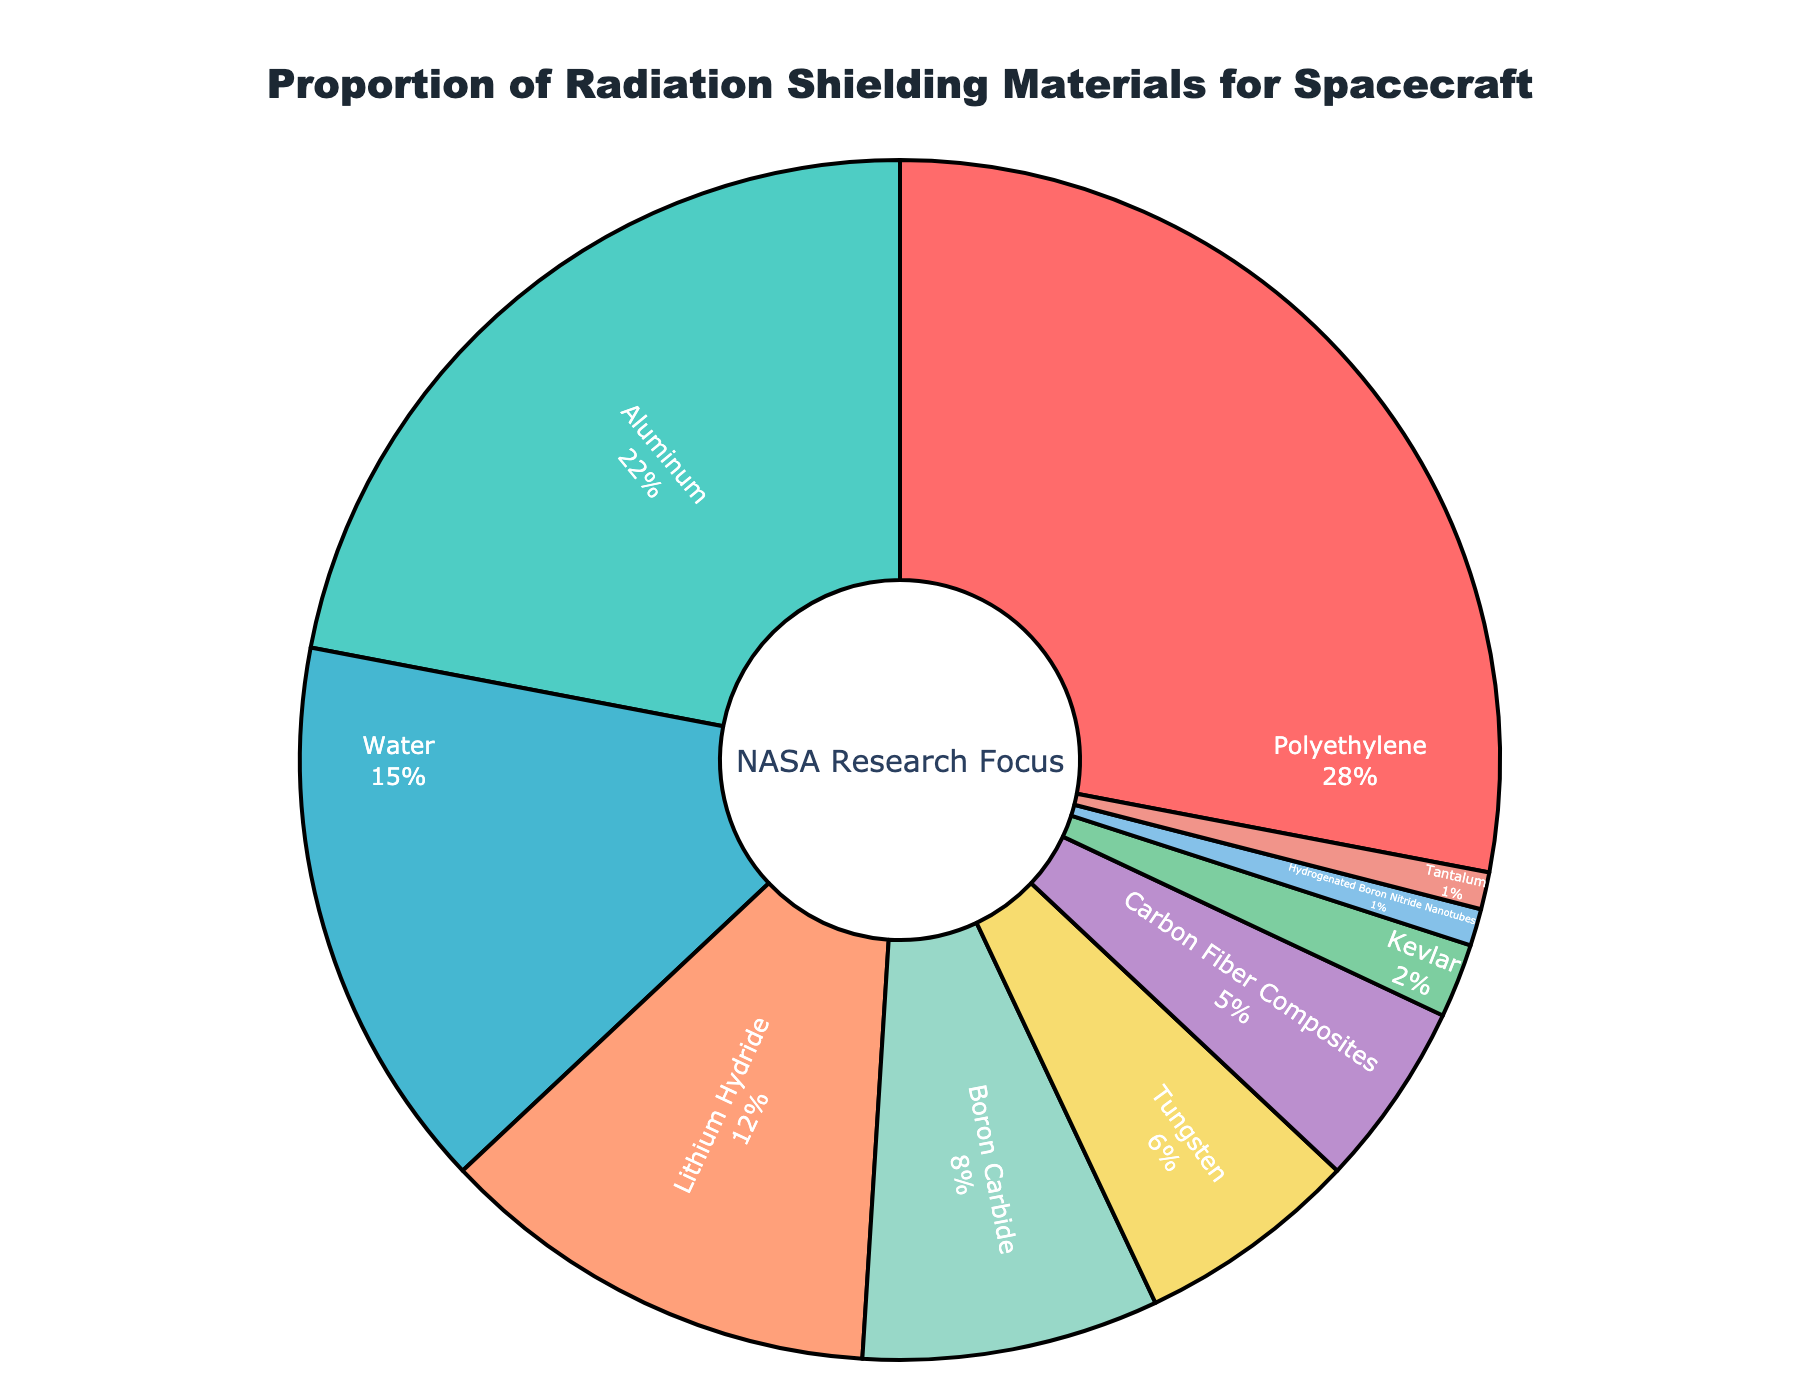What material is the most researched for radiation shielding based on the pie chart? The greatest portion of the pie chart is occupied by Polyethylene, indicating it is the most researched material. This can be directly seen from the visual size of the slices.
Answer: Polyethylene Which materials together comprise more than 50% of the research focus? Adding the percentages of Polyethylene (28%) and Aluminum (22%) gives a sum of 50%, but we need more than 50%, so we include Water (15%) as well. Together they make 28% + 22% + 15% = 65%.
Answer: Polyethylene, Aluminum, Water How does the proportion of research on Aluminum compare to that on Lithium Hydride? The pie chart shows that Aluminum occupies 22% of the research focus while Lithium Hydride occupies 12%. Therefore, Aluminum has a greater proportion than Lithium Hydride.
Answer: Aluminum What is the combined research focus percentage for Boron Carbide and Tungsten? Boron Carbide has 8% and Tungsten has 6%. Adding them together, the combined research focus is 8% + 6% = 14%.
Answer: 14% Which material has the smallest proportion of research focus, and what is that proportion? The smallest slice in the pie chart is occupied by Hydrogenated Boron Nitride Nanotubes and Tantalum, each having a 1% research focus.
Answer: Hydrogenated Boron Nitride Nanotubes, Tantalum (each 1%) If Kevlar's research focus were to double, what would be its new percentage? Kevlar currently has 2% of the research focus. Doubling this would result in 2% * 2 = 4%.
Answer: 4% By how much does Polyethylene exceed Water in terms of research focus? Polyethylene has 28% while Water has 15%. The difference is 28% - 15% = 13%.
Answer: 13% Rank the materials in descending order based on their proportion of research focus. To rank them, we list the percentages in descending order:
Polyethylene (28%), Aluminum (22%), Water (15%), Lithium Hydride (12%), Boron Carbide (8%), Tungsten (6%), Carbon Fiber Composites (5%), Kevlar (2%), Hydrogenated Boron Nitride Nanotubes (1%), Tantalum (1%).
Answer: Polyethylene, Aluminum, Water, Lithium Hydride, Boron Carbide, Tungsten, Carbon Fiber Composites, Kevlar, Hydrogenated Boron Nitride Nanotubes, Tantalum What is the visual difference between the materials that make up the smallest research focus in the chart? Both Hydrogenated Boron Nitride Nanotubes and Tantalum share the smallest proportion at 1% each. The visual distinction is that these slices are very small compared to others in the pie chart.
Answer: Both are very small segments, occupying 1% each What percentage of the research focus is on materials other than Polyethylene and Aluminum combined? Adding up all the percentages except Polyethylene (28%) and Aluminum (22%), we get 15% (Water) + 12% (Lithium Hydride) + 8% (Boron Carbide) + 6% (Tungsten) + 5% (Carbon Fiber Composites) + 2% (Kevlar) + 1% (Hydrogenated Boron Nitride Nanotubes) + 1% (Tantalum) = 50%.
Answer: 50% 